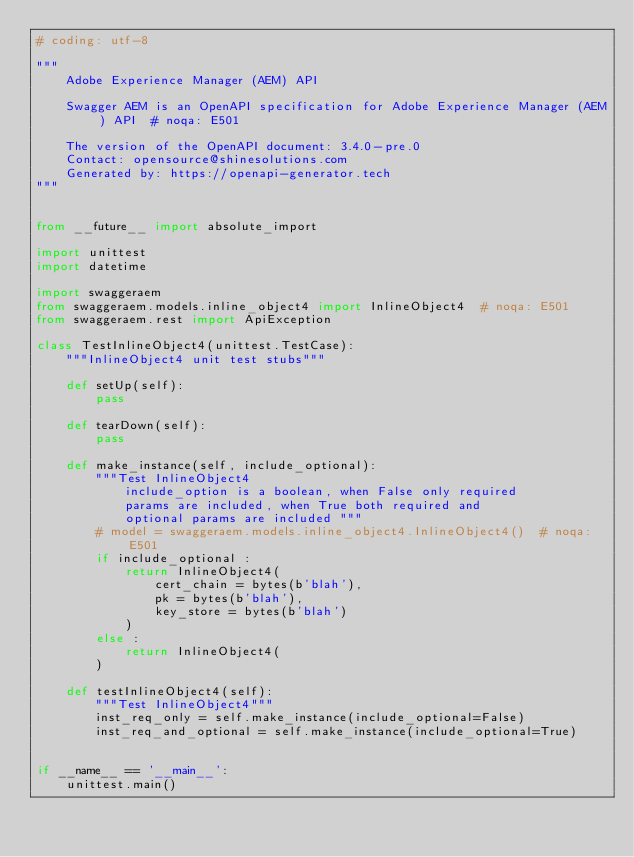Convert code to text. <code><loc_0><loc_0><loc_500><loc_500><_Python_># coding: utf-8

"""
    Adobe Experience Manager (AEM) API

    Swagger AEM is an OpenAPI specification for Adobe Experience Manager (AEM) API  # noqa: E501

    The version of the OpenAPI document: 3.4.0-pre.0
    Contact: opensource@shinesolutions.com
    Generated by: https://openapi-generator.tech
"""


from __future__ import absolute_import

import unittest
import datetime

import swaggeraem
from swaggeraem.models.inline_object4 import InlineObject4  # noqa: E501
from swaggeraem.rest import ApiException

class TestInlineObject4(unittest.TestCase):
    """InlineObject4 unit test stubs"""

    def setUp(self):
        pass

    def tearDown(self):
        pass

    def make_instance(self, include_optional):
        """Test InlineObject4
            include_option is a boolean, when False only required
            params are included, when True both required and
            optional params are included """
        # model = swaggeraem.models.inline_object4.InlineObject4()  # noqa: E501
        if include_optional :
            return InlineObject4(
                cert_chain = bytes(b'blah'), 
                pk = bytes(b'blah'), 
                key_store = bytes(b'blah')
            )
        else :
            return InlineObject4(
        )

    def testInlineObject4(self):
        """Test InlineObject4"""
        inst_req_only = self.make_instance(include_optional=False)
        inst_req_and_optional = self.make_instance(include_optional=True)


if __name__ == '__main__':
    unittest.main()
</code> 